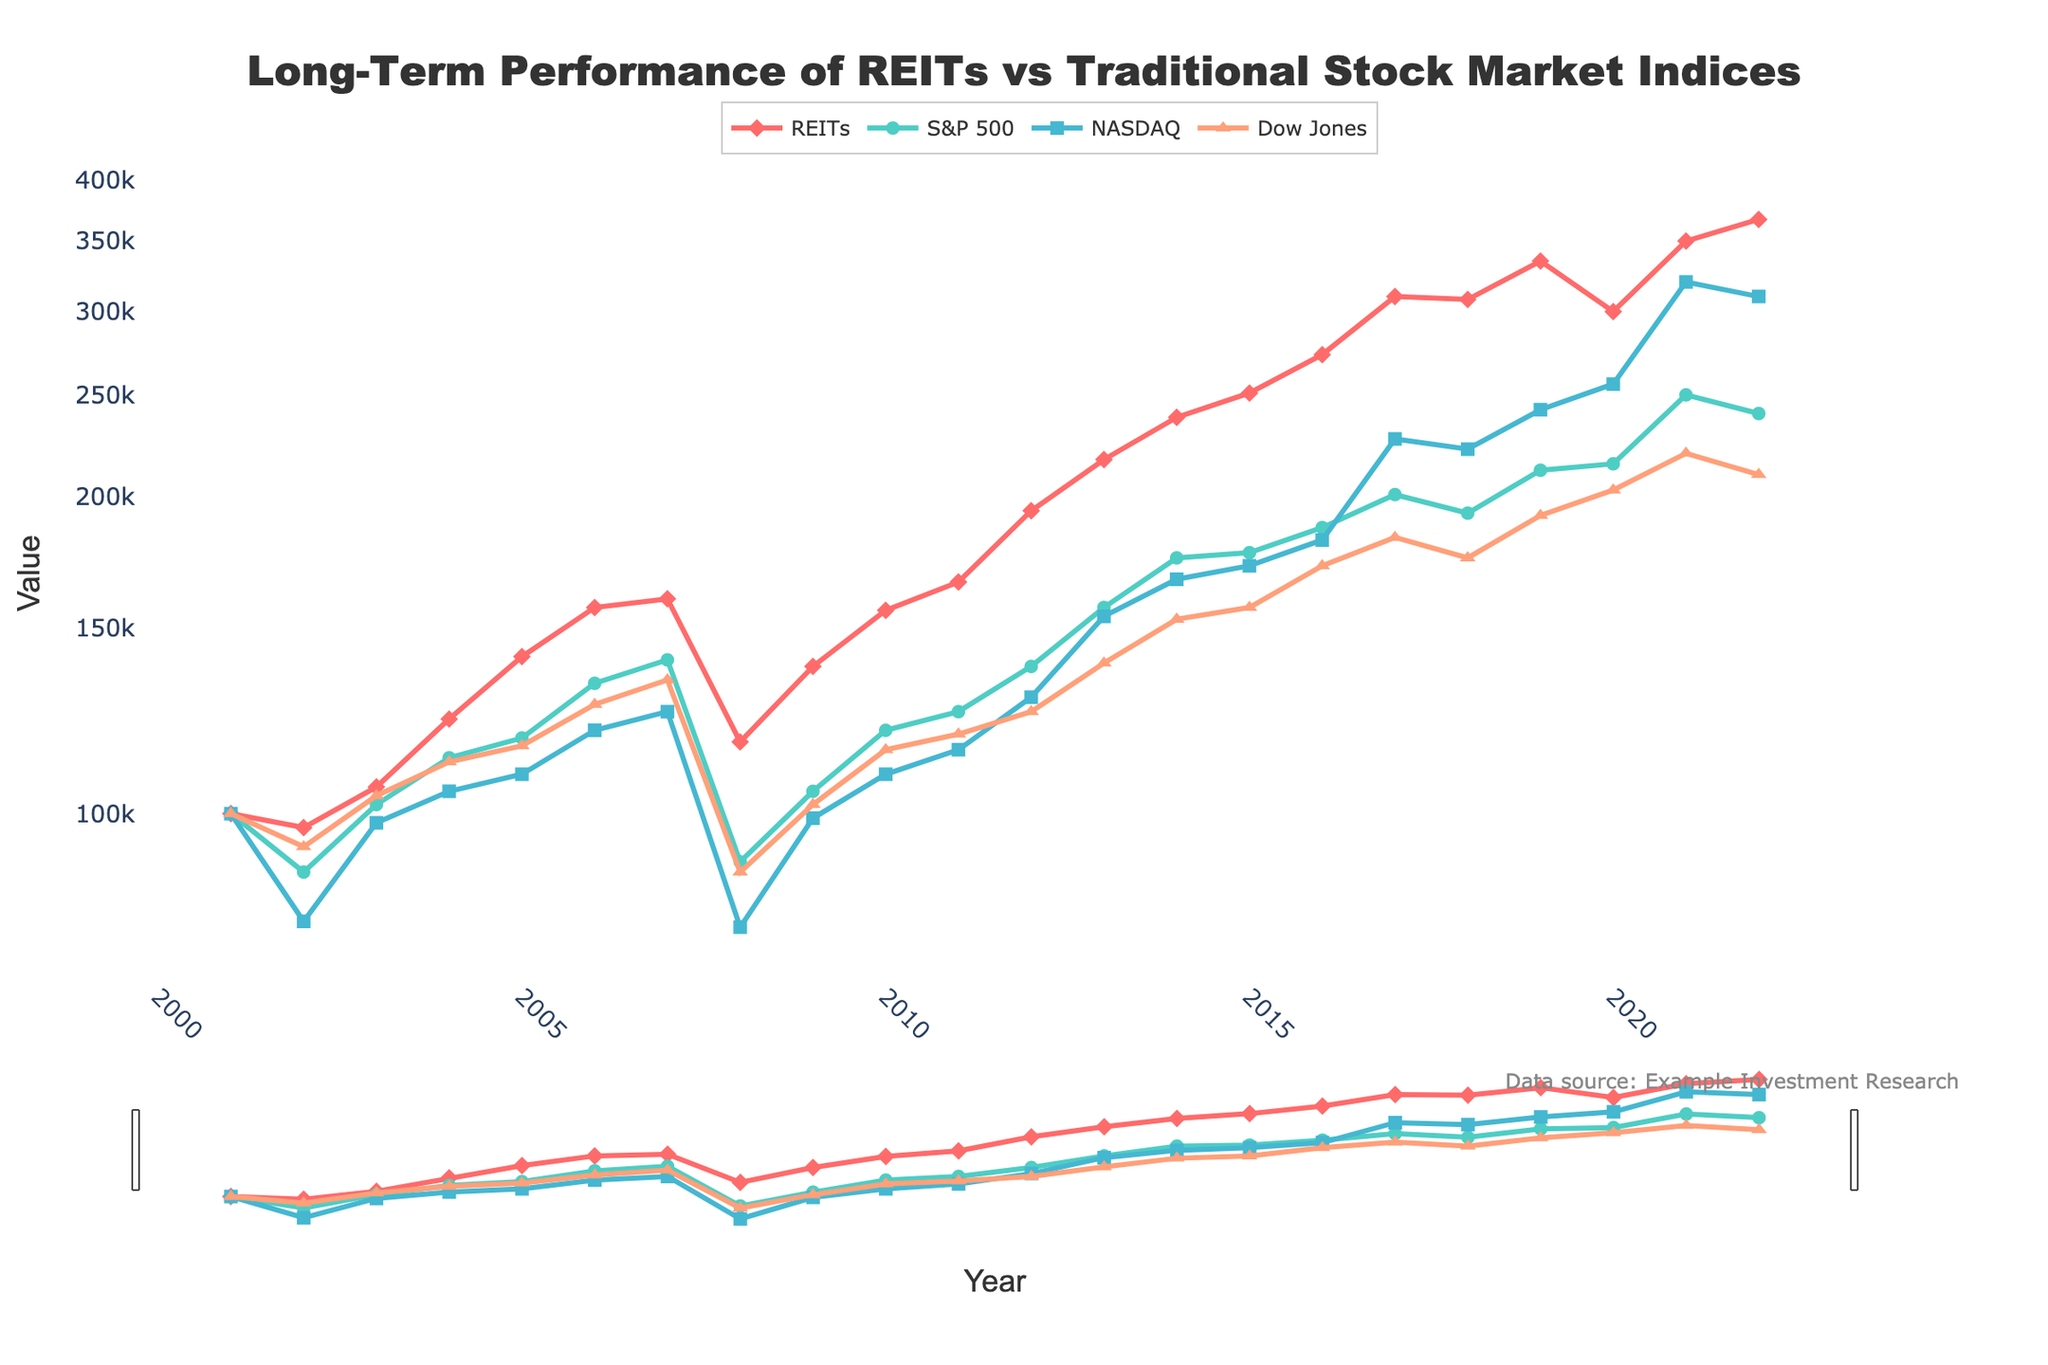What is the title of the plot? The title is displayed at the top of the plot.
Answer: Long-Term Performance of REITs vs Traditional Stock Market Indices What does the y-axis represent? The y-axis represents the value of the investments and is labeled "Value".
Answer: Value How many different indices are compared in the plot? Count the different lines in the plot. Each line represents a different index.
Answer: Four What trend do you see for REITs from 2008 to 2010? Observe the line for REITs and note the change in value from 2008 to 2010.
Answer: An increase Which year shows the lowest value for the NASDAQ index? Identify the lowest point on the NASDAQ line and note the corresponding year.
Answer: 2002 What is the general trend of the S&P 500 from 2001 to 2022? Observe the S&P 500 line from start to end and note the overall direction.
Answer: Upward trend Which index had the highest value in 2021? Compare the values of all indices at the year 2021.
Answer: REITs How did the Dow Jones index perform relative to the S&P 500 in 2008? Compare the values of the Dow Jones and the S&P 500 in 2008.
Answer: Dow Jones performed better What is the proportional change in the value of REITs from 2001 to 2022? Calculate the change from 100,000 in 2001 to 367,000 in 2022, then find the proportion.
Answer: 3.67 times Between which years did the REITs index experience the most significant growth? Identify the section of the REITs line with the steepest positive slope.
Answer: 2008 to 2017 